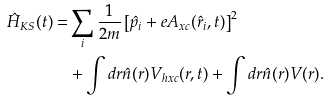<formula> <loc_0><loc_0><loc_500><loc_500>\hat { H } _ { K S } ( t ) = & \sum _ { i } \frac { 1 } { 2 m } \left [ \hat { p } _ { i } + e A _ { x c } ( \hat { r } _ { i } , t ) \right ] ^ { 2 } \\ & + \int d r \hat { n } ( r ) V _ { h x c } ( r , t ) + \int d r \hat { n } ( r ) V ( r ) .</formula> 